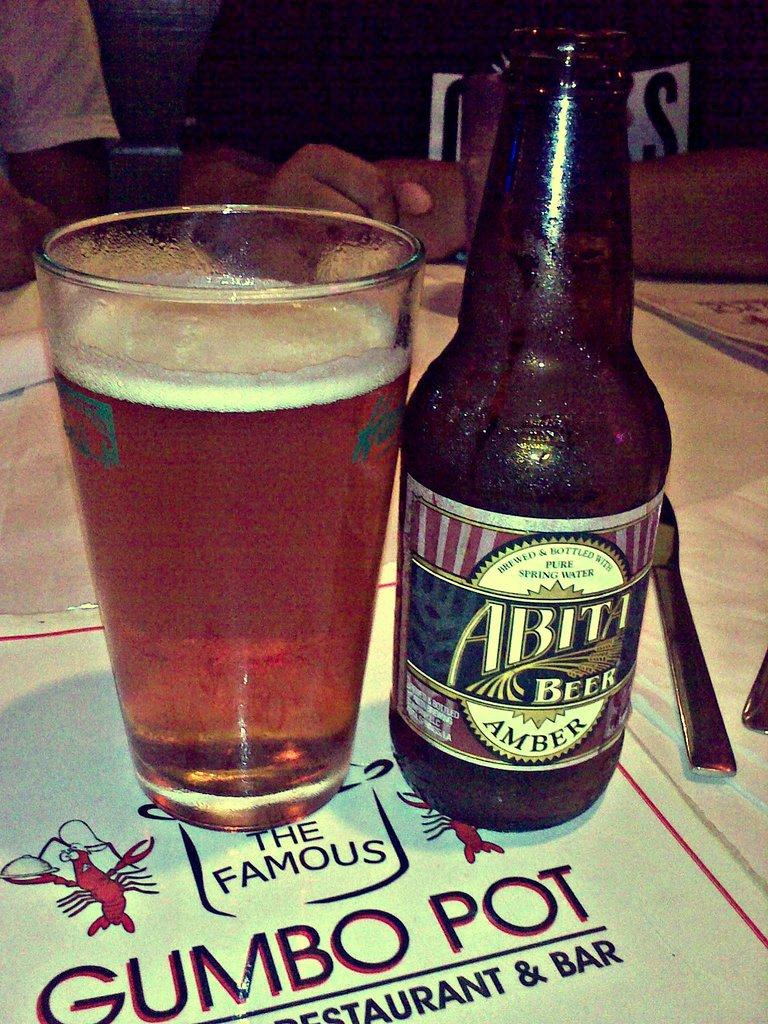What´s the name of the beer?
Provide a succinct answer. Abita. 